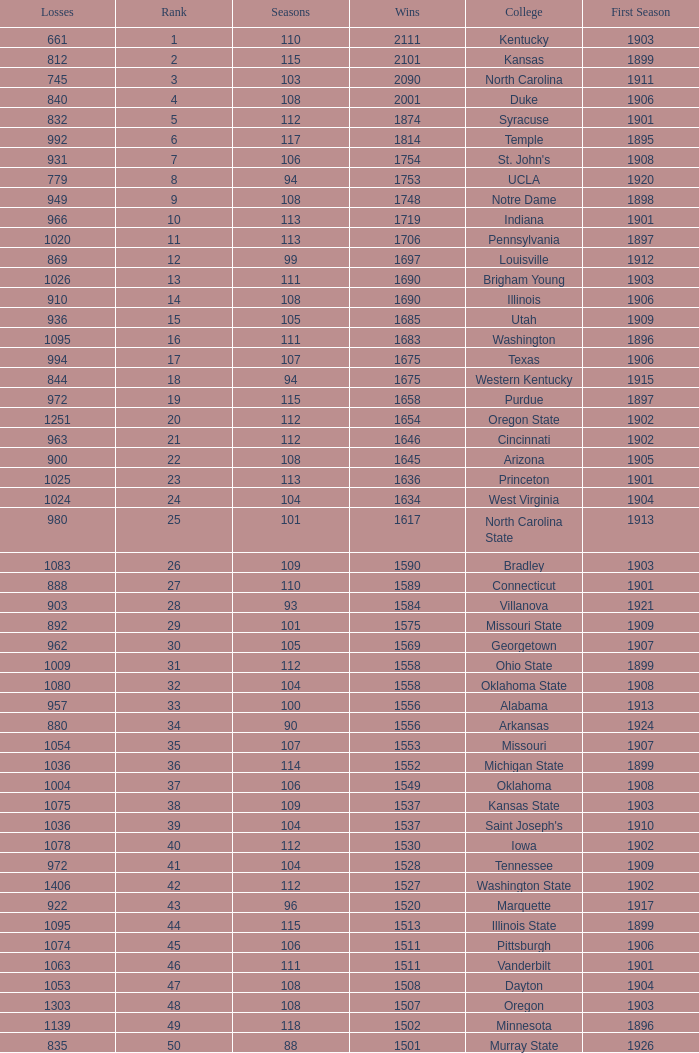How many wins were there for Washington State College with losses greater than 980 and a first season before 1906 and rank greater than 42? 0.0. 